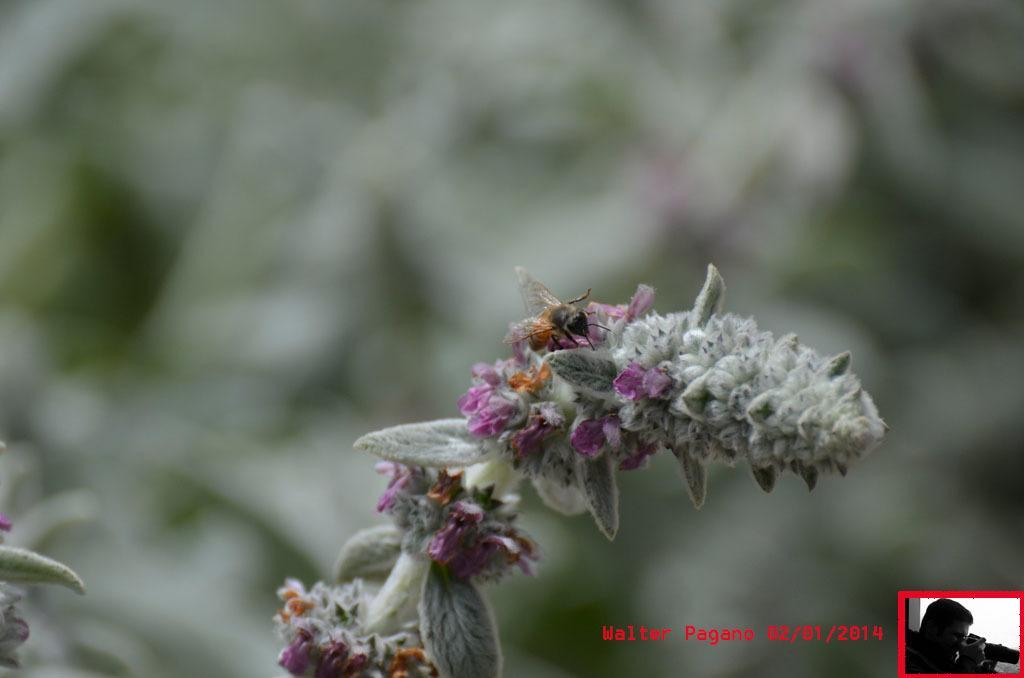In one or two sentences, can you explain what this image depicts? This image consists of a honey bee sitting on a flower or a plant. The background, is blurred. 